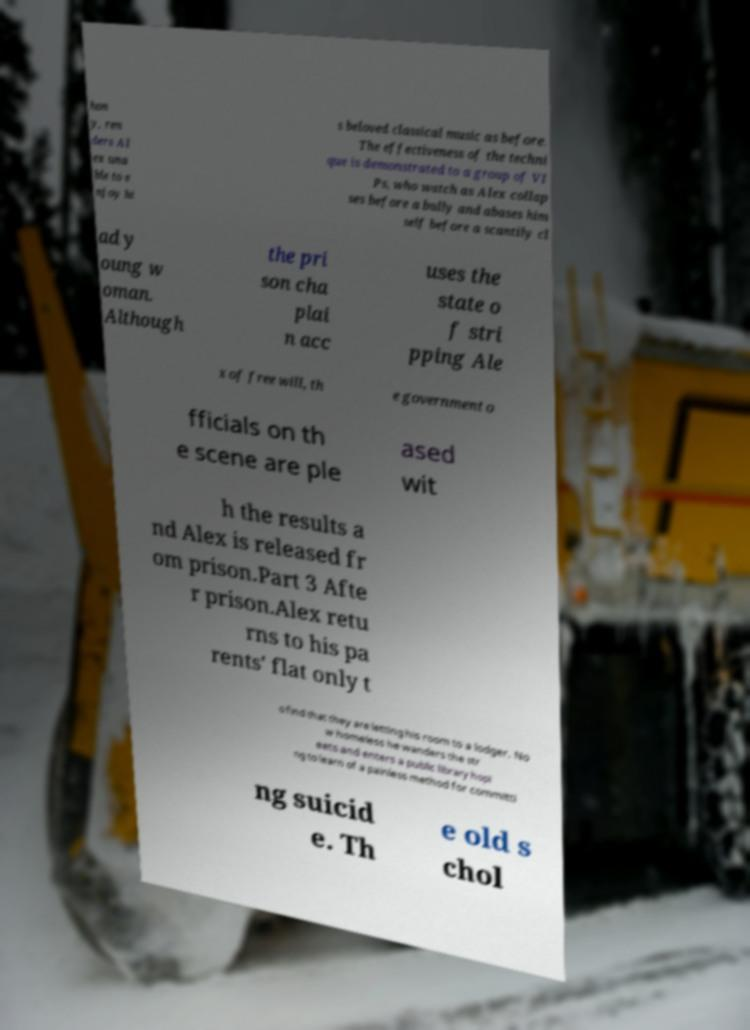Can you read and provide the text displayed in the image?This photo seems to have some interesting text. Can you extract and type it out for me? hon y, ren ders Al ex una ble to e njoy hi s beloved classical music as before. The effectiveness of the techni que is demonstrated to a group of VI Ps, who watch as Alex collap ses before a bully and abases him self before a scantily cl ad y oung w oman. Although the pri son cha plai n acc uses the state o f stri pping Ale x of free will, th e government o fficials on th e scene are ple ased wit h the results a nd Alex is released fr om prison.Part 3 Afte r prison.Alex retu rns to his pa rents' flat only t o find that they are letting his room to a lodger. No w homeless he wanders the str eets and enters a public library hopi ng to learn of a painless method for committi ng suicid e. Th e old s chol 